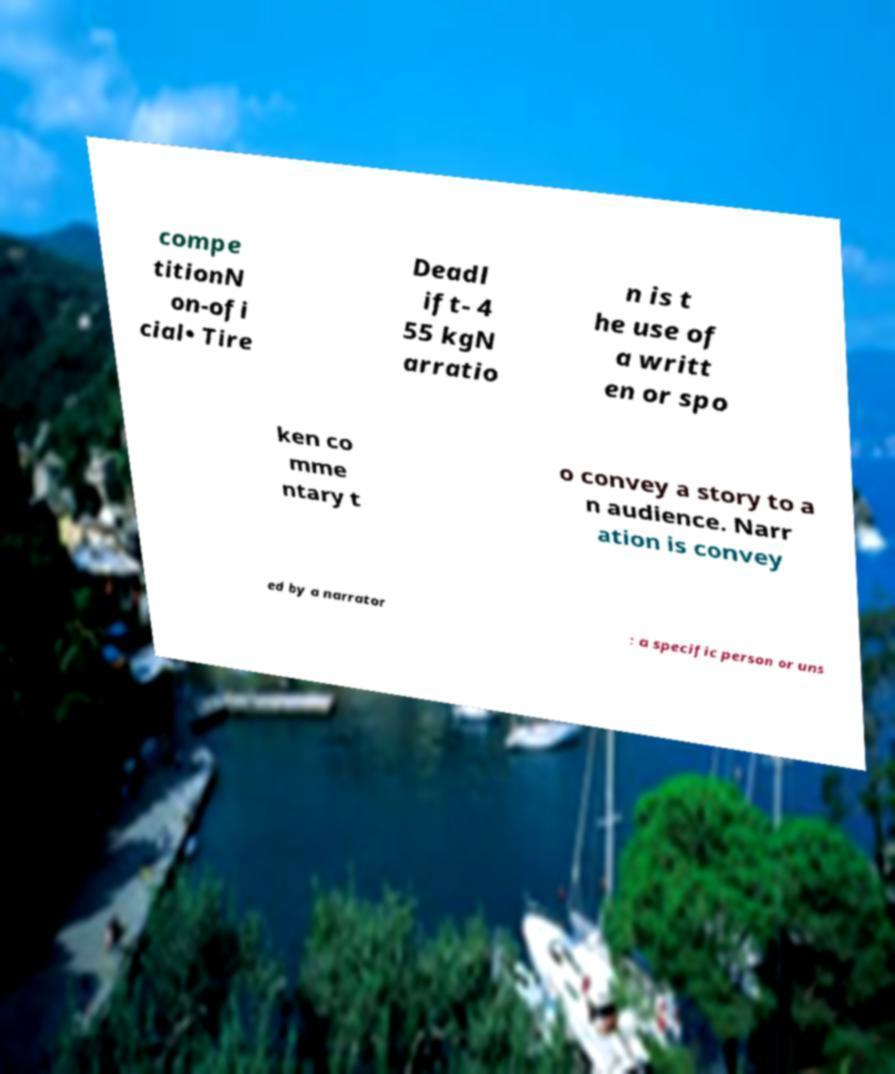Could you extract and type out the text from this image? compe titionN on-ofi cial• Tire Deadl ift- 4 55 kgN arratio n is t he use of a writt en or spo ken co mme ntary t o convey a story to a n audience. Narr ation is convey ed by a narrator : a specific person or uns 